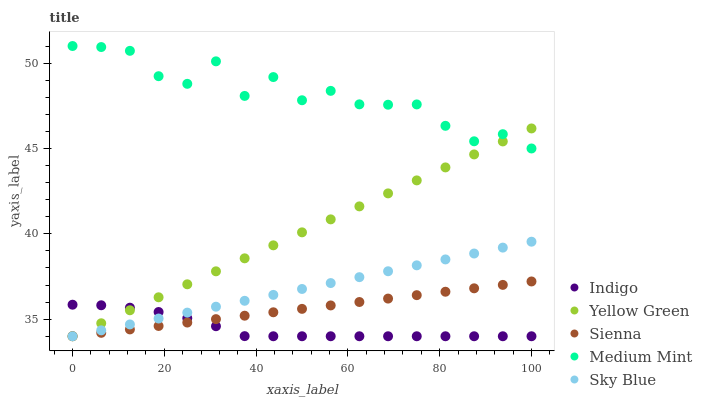Does Indigo have the minimum area under the curve?
Answer yes or no. Yes. Does Medium Mint have the maximum area under the curve?
Answer yes or no. Yes. Does Medium Mint have the minimum area under the curve?
Answer yes or no. No. Does Indigo have the maximum area under the curve?
Answer yes or no. No. Is Yellow Green the smoothest?
Answer yes or no. Yes. Is Medium Mint the roughest?
Answer yes or no. Yes. Is Indigo the smoothest?
Answer yes or no. No. Is Indigo the roughest?
Answer yes or no. No. Does Sienna have the lowest value?
Answer yes or no. Yes. Does Medium Mint have the lowest value?
Answer yes or no. No. Does Medium Mint have the highest value?
Answer yes or no. Yes. Does Indigo have the highest value?
Answer yes or no. No. Is Indigo less than Medium Mint?
Answer yes or no. Yes. Is Medium Mint greater than Sky Blue?
Answer yes or no. Yes. Does Yellow Green intersect Sky Blue?
Answer yes or no. Yes. Is Yellow Green less than Sky Blue?
Answer yes or no. No. Is Yellow Green greater than Sky Blue?
Answer yes or no. No. Does Indigo intersect Medium Mint?
Answer yes or no. No. 